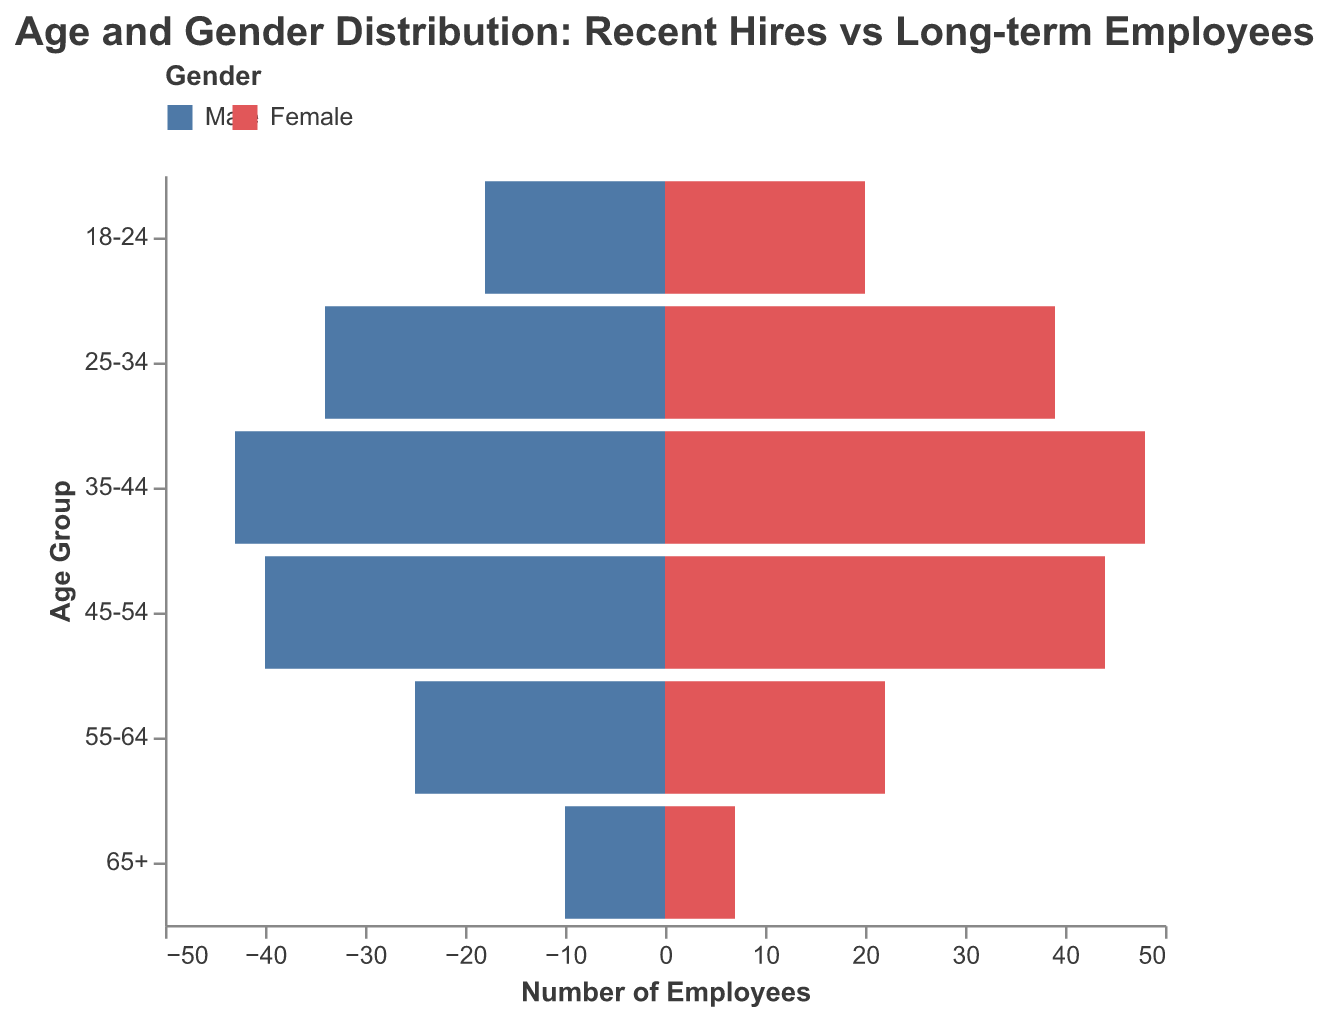what is the title of the figure? The title of the figure is often located at the top and gives a brief description of the figure's content. The title in this case reads, "Age and Gender Distribution: Recent Hires vs Long-term Employees."
Answer: Age and Gender Distribution: Recent Hires vs Long-term Employees what does the x-axis represent? The x-axis generally represents the variable being measured across different groups. Here, it shows the number of employees, with negative values for Male employees and positive values for Female employees.
Answer: Number of Employees what age group has the highest number of female long-term employees? To determine the highest number of female long-term employees, we compare the values across the age groups. The 45-54 age group has the highest number at 32.
Answer: 45-54 how many male recent hires are there in the 25-34 age group? By examining the data for the 25-34 age group under the column "Male Recent Hires," we can see that there are 22 male recent hires.
Answer: 22 what is the total number of employees in the 35-44 age group? Adding the total numbers of recent hires and long-term employees for both genders in the 35-44 age group: (18 male recent hires + 20 female recent hires + 25 male long-term employees + 28 female long-term employees) results in 91.
Answer: 91 are there more female or male employees in the 55-64 age group? Summing up the numbers for the 55-64 age group gives us:
Male employees = 5 (recent) + 20 (long-term) = 25
Female employees = 4 (recent) + 18 (long-term) = 22 
So, there are more male employees.
Answer: Male which age group shows the greatest gender diversity among recent hires? Gender diversity can be gauged by comparing the recent hire numbers for both genders within age groups. The 18-24 group shows a fairly equal distribution with 15 male and 18 female recent hires.
Answer: 18-24 how does the number of female recent hires compare to female long-term employees in the 65+ age group? For the 65+ age group, the number of female recent hires is 1, while the number of female long-term employees is 6. This shows that there are significantly fewer female recent hires compared to female long-term employees.
Answer: Fewer what age group has the least number of long-term employees? We add the male and female long-term employees for each age group and compare. The 18-24 age group has the fewest long-term employees with only 3 males and 2 females, totaling 5.
Answer: 18-24 how many total recent hires are there? Summing up the values for male and female recent hires across all age groups gives:
Male (15 + 22 + 18 + 10 + 5 + 2) = 72
Female (18 + 25 + 20 + 12 + 4 + 1) = 80
Total recent hires = 72 + 80 = 152.
Answer: 152 